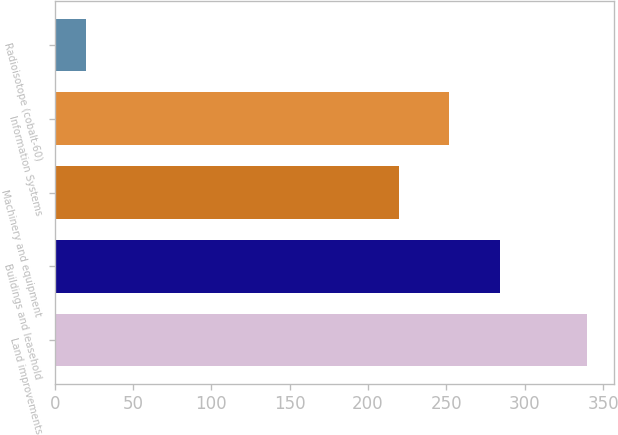<chart> <loc_0><loc_0><loc_500><loc_500><bar_chart><fcel>Land improvements<fcel>Buildings and leasehold<fcel>Machinery and equipment<fcel>Information Systems<fcel>Radioisotope (cobalt-60)<nl><fcel>340<fcel>284<fcel>220<fcel>252<fcel>20<nl></chart> 